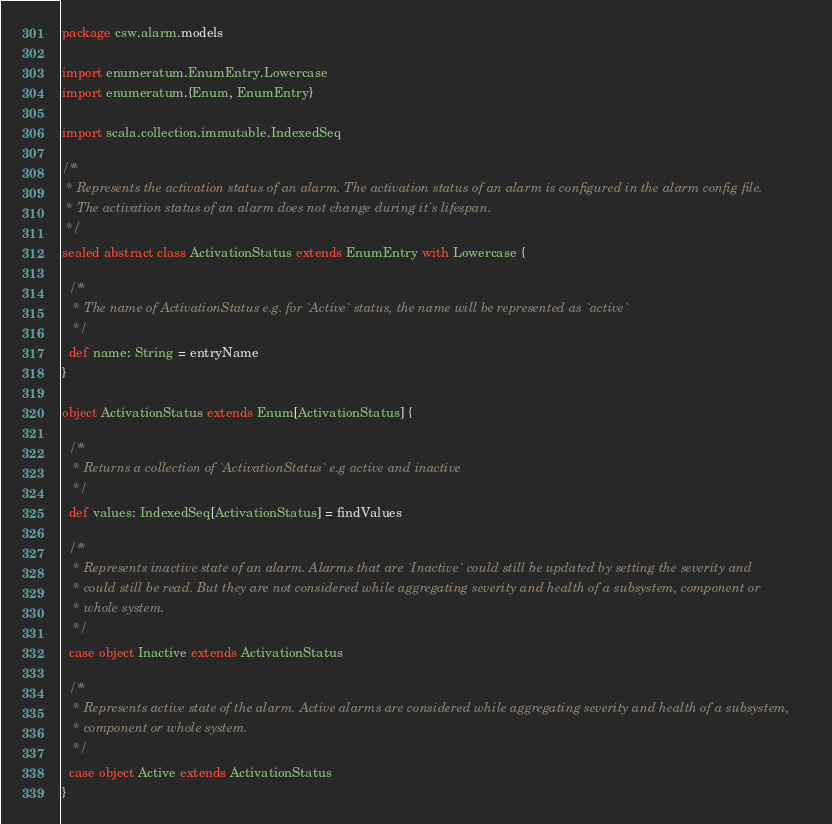Convert code to text. <code><loc_0><loc_0><loc_500><loc_500><_Scala_>package csw.alarm.models

import enumeratum.EnumEntry.Lowercase
import enumeratum.{Enum, EnumEntry}

import scala.collection.immutable.IndexedSeq

/**
 * Represents the activation status of an alarm. The activation status of an alarm is configured in the alarm config file.
 * The activation status of an alarm does not change during it's lifespan.
 */
sealed abstract class ActivationStatus extends EnumEntry with Lowercase {

  /**
   * The name of ActivationStatus e.g. for `Active` status, the name will be represented as `active`
   */
  def name: String = entryName
}

object ActivationStatus extends Enum[ActivationStatus] {

  /**
   * Returns a collection of `ActivationStatus` e.g active and inactive
   */
  def values: IndexedSeq[ActivationStatus] = findValues

  /**
   * Represents inactive state of an alarm. Alarms that are `Inactive` could still be updated by setting the severity and
   * could still be read. But they are not considered while aggregating severity and health of a subsystem, component or
   * whole system.
   */
  case object Inactive extends ActivationStatus

  /**
   * Represents active state of the alarm. Active alarms are considered while aggregating severity and health of a subsystem,
   * component or whole system.
   */
  case object Active extends ActivationStatus
}
</code> 